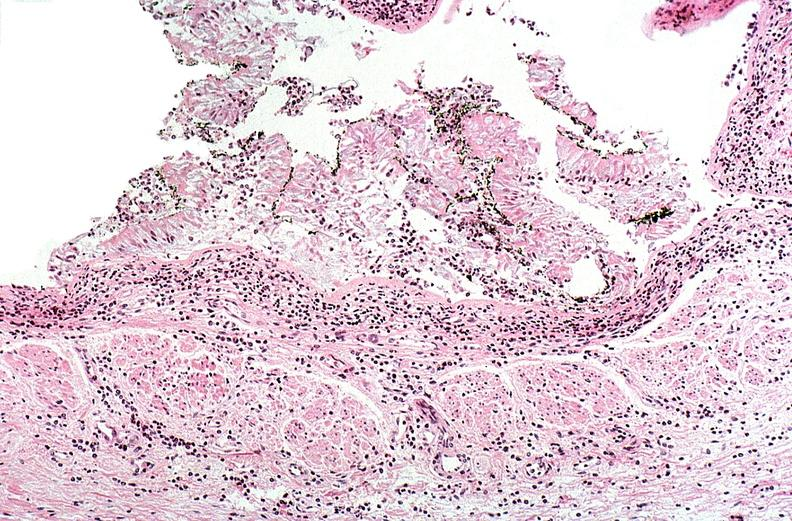does this image show thermal burn?
Answer the question using a single word or phrase. Yes 